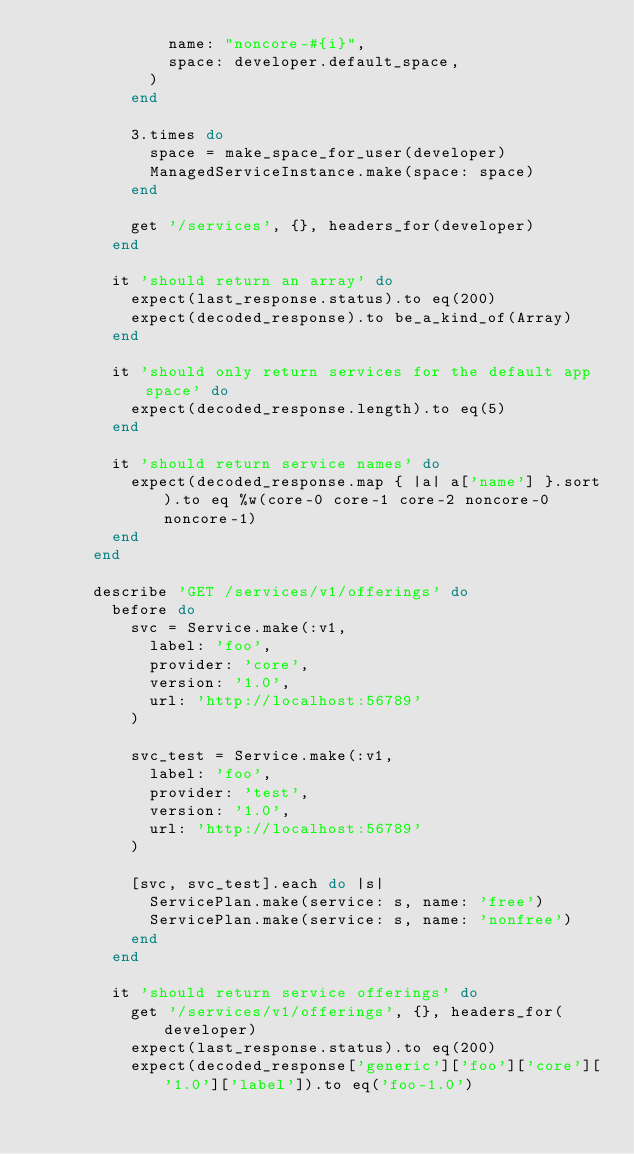<code> <loc_0><loc_0><loc_500><loc_500><_Ruby_>              name: "noncore-#{i}",
              space: developer.default_space,
            )
          end

          3.times do
            space = make_space_for_user(developer)
            ManagedServiceInstance.make(space: space)
          end

          get '/services', {}, headers_for(developer)
        end

        it 'should return an array' do
          expect(last_response.status).to eq(200)
          expect(decoded_response).to be_a_kind_of(Array)
        end

        it 'should only return services for the default app space' do
          expect(decoded_response.length).to eq(5)
        end

        it 'should return service names' do
          expect(decoded_response.map { |a| a['name'] }.sort).to eq %w(core-0 core-1 core-2 noncore-0 noncore-1)
        end
      end

      describe 'GET /services/v1/offerings' do
        before do
          svc = Service.make(:v1,
            label: 'foo',
            provider: 'core',
            version: '1.0',
            url: 'http://localhost:56789'
          )

          svc_test = Service.make(:v1,
            label: 'foo',
            provider: 'test',
            version: '1.0',
            url: 'http://localhost:56789'
          )

          [svc, svc_test].each do |s|
            ServicePlan.make(service: s, name: 'free')
            ServicePlan.make(service: s, name: 'nonfree')
          end
        end

        it 'should return service offerings' do
          get '/services/v1/offerings', {}, headers_for(developer)
          expect(last_response.status).to eq(200)
          expect(decoded_response['generic']['foo']['core']['1.0']['label']).to eq('foo-1.0')</code> 